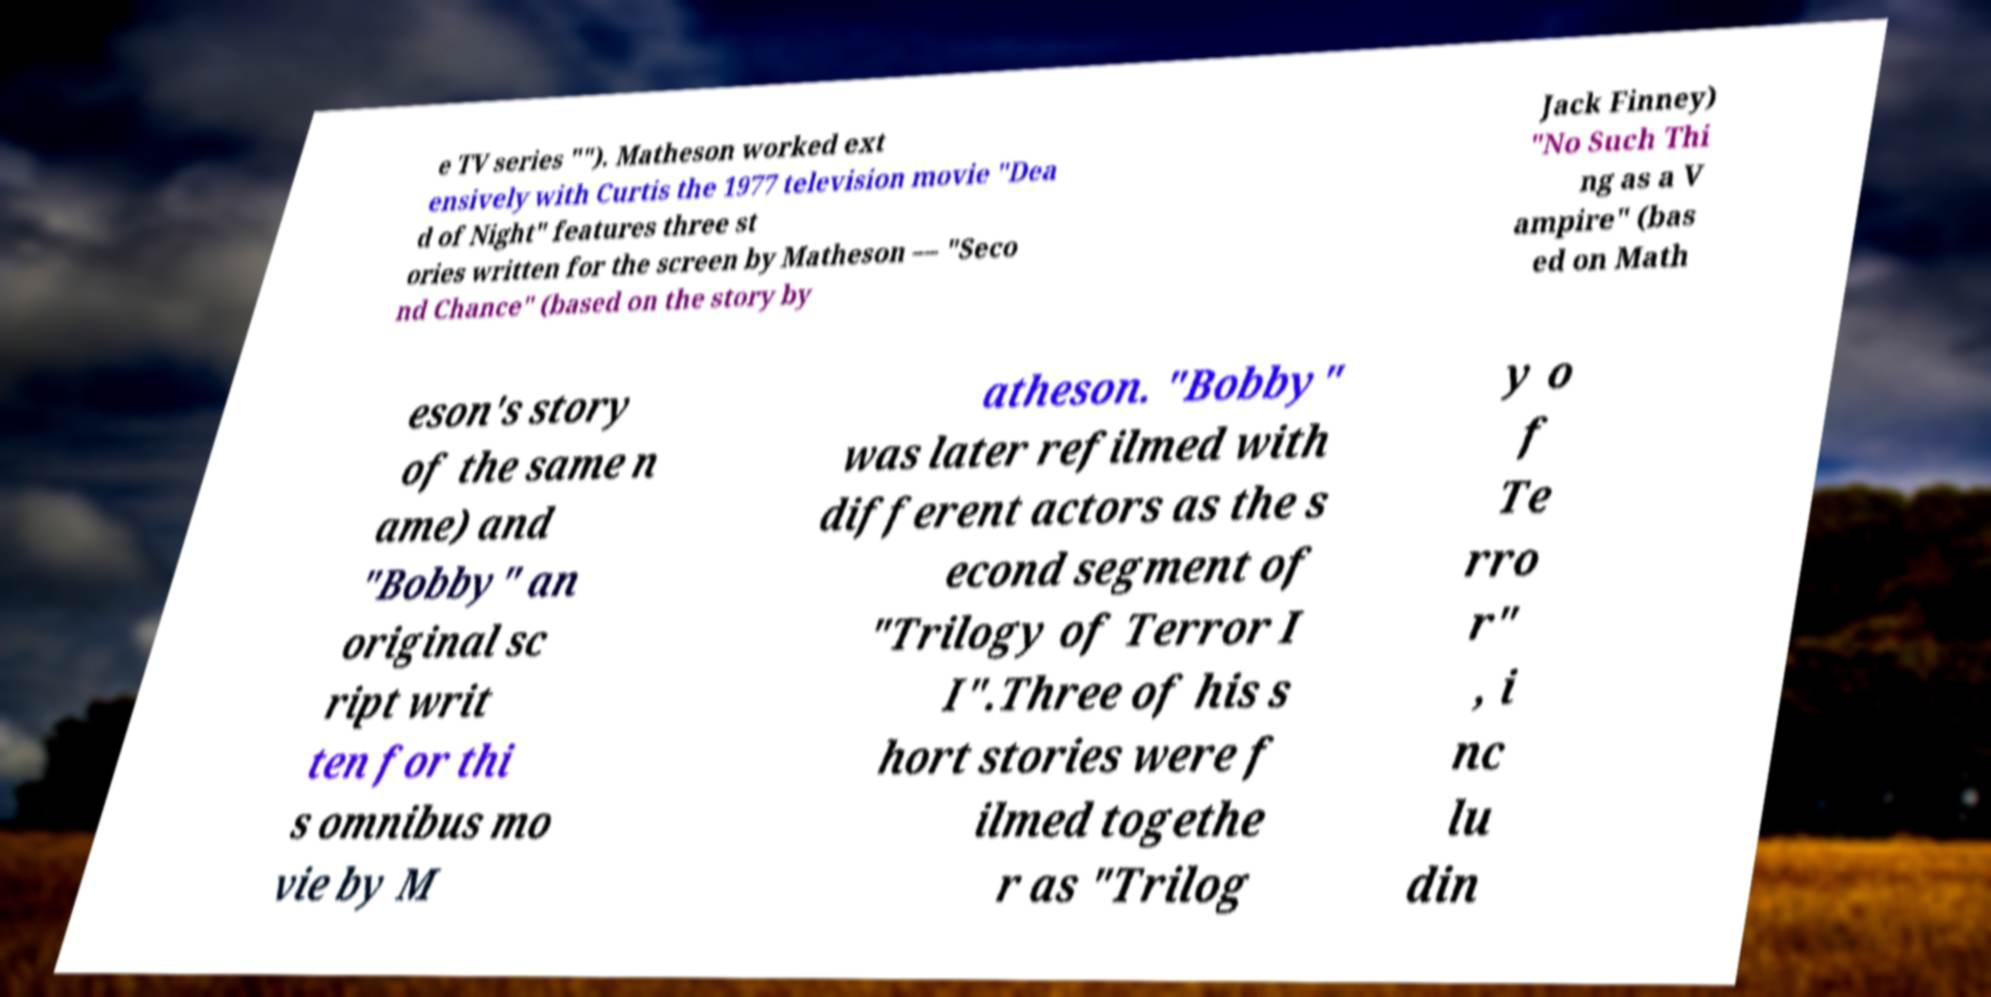For documentation purposes, I need the text within this image transcribed. Could you provide that? e TV series ""). Matheson worked ext ensively with Curtis the 1977 television movie "Dea d of Night" features three st ories written for the screen by Matheson — "Seco nd Chance" (based on the story by Jack Finney) "No Such Thi ng as a V ampire" (bas ed on Math eson's story of the same n ame) and "Bobby" an original sc ript writ ten for thi s omnibus mo vie by M atheson. "Bobby" was later refilmed with different actors as the s econd segment of "Trilogy of Terror I I".Three of his s hort stories were f ilmed togethe r as "Trilog y o f Te rro r" , i nc lu din 